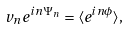<formula> <loc_0><loc_0><loc_500><loc_500>v _ { n } e ^ { i n \Psi _ { n } } = \langle e ^ { i n \phi } \rangle ,</formula> 